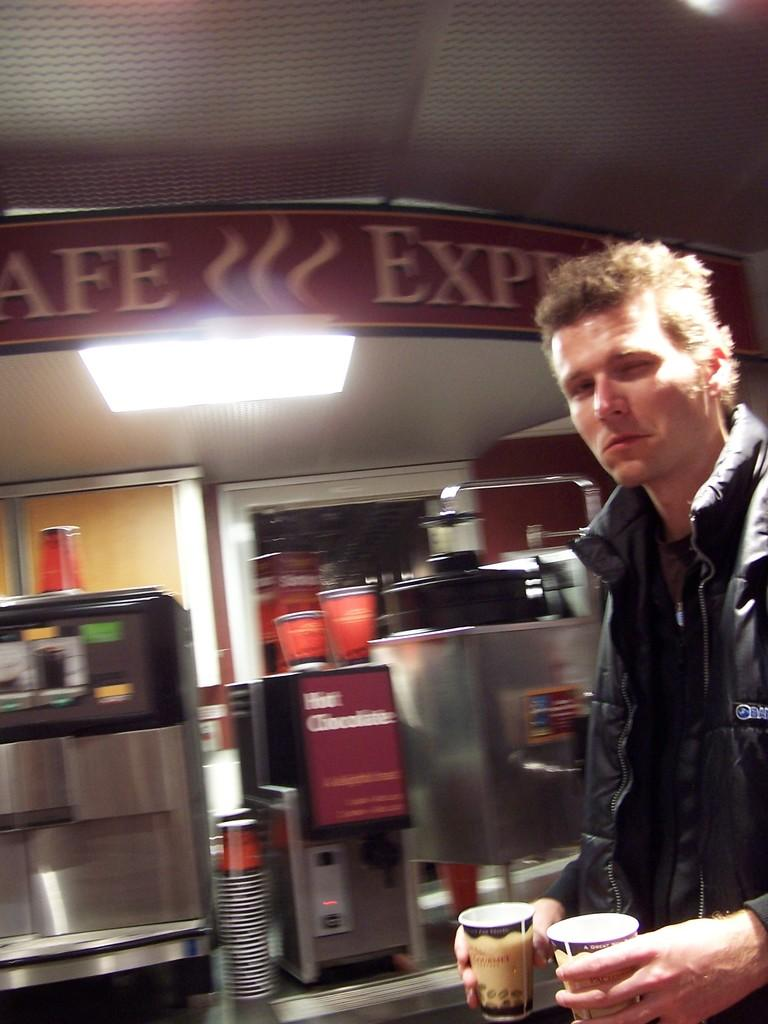Provide a one-sentence caption for the provided image. A man stands in front of a hot chocolate machine. 